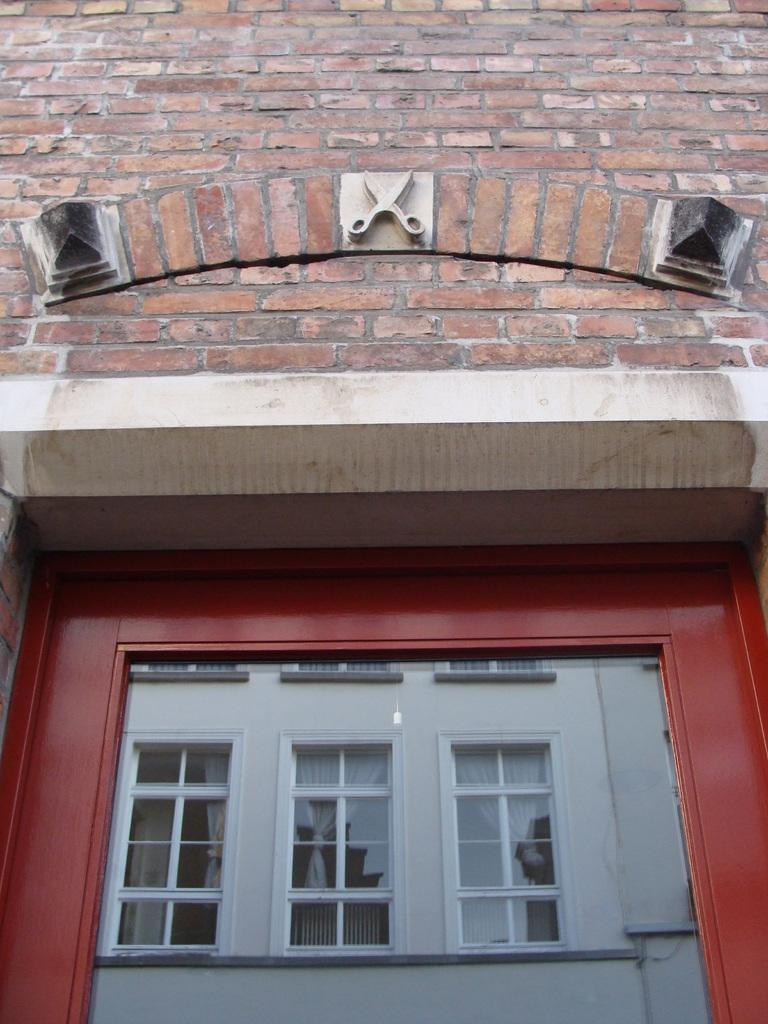What type of door is present on the building in the image? There is a glass door on the building in the image. What can be seen in the reflection of the glass door? The glass door reflects another building. What type of engine is visible in the image? There is no engine present in the image. Is there a person wearing a scarf in the image? There is no person or scarf visible in the image. 